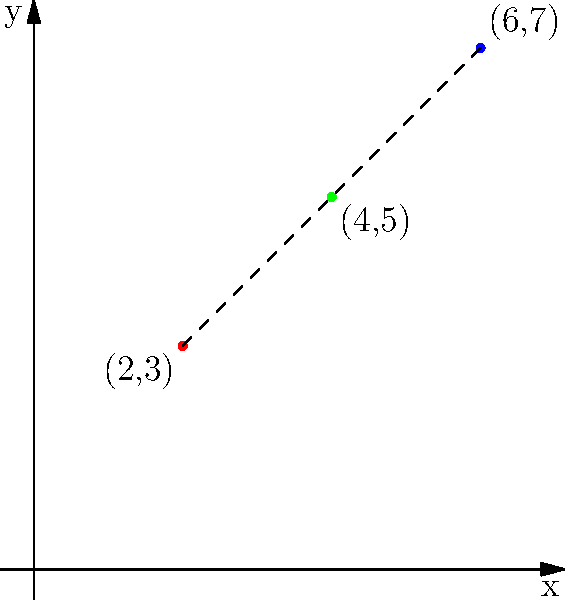In your exploration of different teaching styles, you've plotted two approaches on a coordinate system. The traditional method is represented by the point (2,3), while the progressive method is at (6,7). To find a balanced approach, you need to determine the midpoint between these two styles. What are the coordinates of this balanced teaching approach? To find the midpoint between two coordinates, we follow these steps:

1. Identify the coordinates:
   - Traditional method: $(x_1, y_1) = (2, 3)$
   - Progressive method: $(x_2, y_2) = (6, 7)$

2. Use the midpoint formula:
   $(\frac{x_1 + x_2}{2}, \frac{y_1 + y_2}{2})$

3. Calculate the x-coordinate of the midpoint:
   $x = \frac{x_1 + x_2}{2} = \frac{2 + 6}{2} = \frac{8}{2} = 4$

4. Calculate the y-coordinate of the midpoint:
   $y = \frac{y_1 + y_2}{2} = \frac{3 + 7}{2} = \frac{10}{2} = 5$

5. Combine the results:
   The midpoint coordinates are $(4, 5)$

This point represents a balanced approach between the traditional and progressive teaching styles.
Answer: (4, 5) 